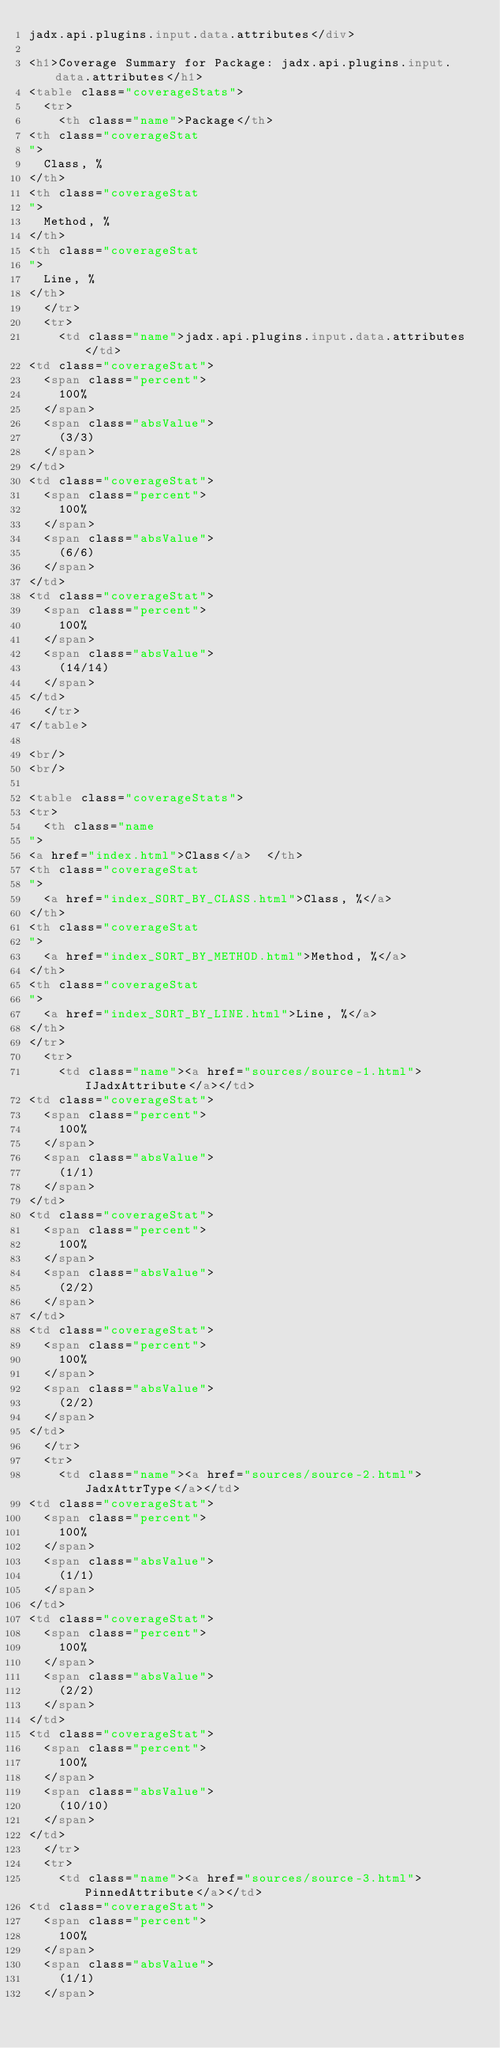Convert code to text. <code><loc_0><loc_0><loc_500><loc_500><_HTML_>jadx.api.plugins.input.data.attributes</div>

<h1>Coverage Summary for Package: jadx.api.plugins.input.data.attributes</h1>
<table class="coverageStats">
  <tr>
    <th class="name">Package</th>
<th class="coverageStat 
">
  Class, %
</th>
<th class="coverageStat 
">
  Method, %
</th>
<th class="coverageStat 
">
  Line, %
</th>
  </tr>
  <tr>
    <td class="name">jadx.api.plugins.input.data.attributes</td>
<td class="coverageStat">
  <span class="percent">
    100%
  </span>
  <span class="absValue">
    (3/3)
  </span>
</td>
<td class="coverageStat">
  <span class="percent">
    100%
  </span>
  <span class="absValue">
    (6/6)
  </span>
</td>
<td class="coverageStat">
  <span class="percent">
    100%
  </span>
  <span class="absValue">
    (14/14)
  </span>
</td>
  </tr>
</table>

<br/>
<br/>

<table class="coverageStats">
<tr>
  <th class="name  
">
<a href="index.html">Class</a>  </th>
<th class="coverageStat 
">
  <a href="index_SORT_BY_CLASS.html">Class, %</a>
</th>
<th class="coverageStat 
">
  <a href="index_SORT_BY_METHOD.html">Method, %</a>
</th>
<th class="coverageStat 
">
  <a href="index_SORT_BY_LINE.html">Line, %</a>
</th>
</tr>
  <tr>
    <td class="name"><a href="sources/source-1.html">IJadxAttribute</a></td>
<td class="coverageStat">
  <span class="percent">
    100%
  </span>
  <span class="absValue">
    (1/1)
  </span>
</td>
<td class="coverageStat">
  <span class="percent">
    100%
  </span>
  <span class="absValue">
    (2/2)
  </span>
</td>
<td class="coverageStat">
  <span class="percent">
    100%
  </span>
  <span class="absValue">
    (2/2)
  </span>
</td>
  </tr>
  <tr>
    <td class="name"><a href="sources/source-2.html">JadxAttrType</a></td>
<td class="coverageStat">
  <span class="percent">
    100%
  </span>
  <span class="absValue">
    (1/1)
  </span>
</td>
<td class="coverageStat">
  <span class="percent">
    100%
  </span>
  <span class="absValue">
    (2/2)
  </span>
</td>
<td class="coverageStat">
  <span class="percent">
    100%
  </span>
  <span class="absValue">
    (10/10)
  </span>
</td>
  </tr>
  <tr>
    <td class="name"><a href="sources/source-3.html">PinnedAttribute</a></td>
<td class="coverageStat">
  <span class="percent">
    100%
  </span>
  <span class="absValue">
    (1/1)
  </span></code> 